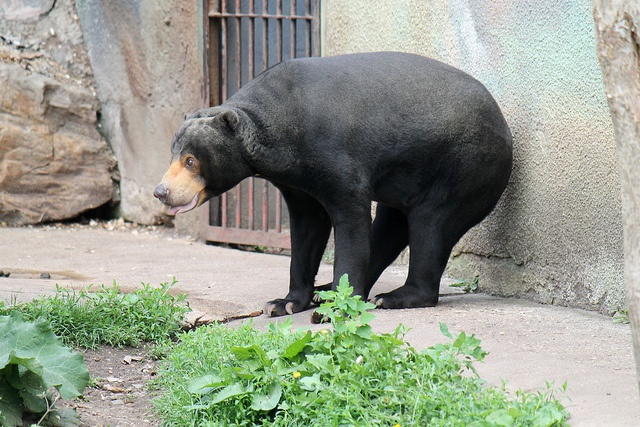Describe the objects in this image and their specific colors. I can see a bear in lightgray, black, gray, and darkgray tones in this image. 